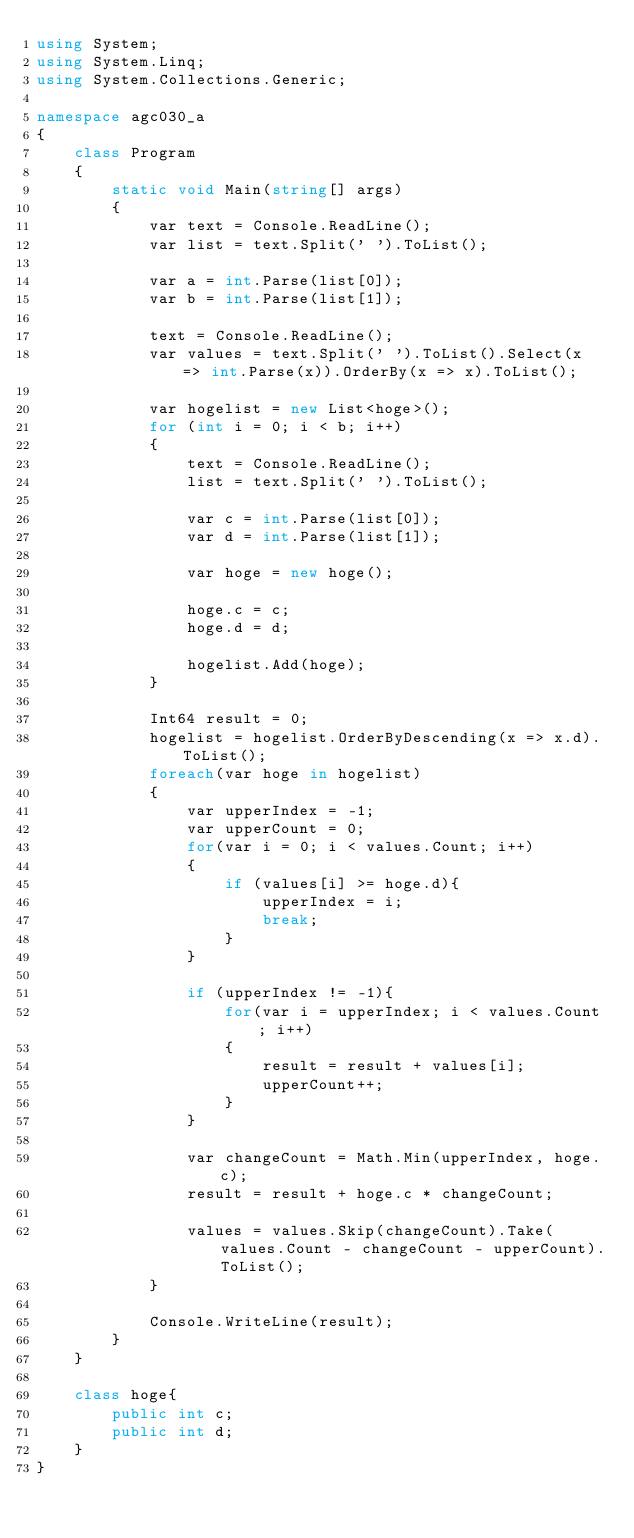<code> <loc_0><loc_0><loc_500><loc_500><_C#_>using System;
using System.Linq;
using System.Collections.Generic;

namespace agc030_a
{
    class Program
    {
        static void Main(string[] args)
        {
            var text = Console.ReadLine();
            var list = text.Split(' ').ToList();

            var a = int.Parse(list[0]);
            var b = int.Parse(list[1]);

            text = Console.ReadLine();
            var values = text.Split(' ').ToList().Select(x => int.Parse(x)).OrderBy(x => x).ToList();

            var hogelist = new List<hoge>();
            for (int i = 0; i < b; i++)
            {
                text = Console.ReadLine();
                list = text.Split(' ').ToList();

                var c = int.Parse(list[0]);
                var d = int.Parse(list[1]);

                var hoge = new hoge();

                hoge.c = c;
                hoge.d = d;

                hogelist.Add(hoge);
            }

            Int64 result = 0;
            hogelist = hogelist.OrderByDescending(x => x.d).ToList();
            foreach(var hoge in hogelist)
            {
                var upperIndex = -1;
                var upperCount = 0;
                for(var i = 0; i < values.Count; i++)
                {
                    if (values[i] >= hoge.d){
                        upperIndex = i;
                        break;
                    }
                }

                if (upperIndex != -1){
                    for(var i = upperIndex; i < values.Count; i++)
                    {
                        result = result + values[i];
                        upperCount++;
                    }
                }
                
                var changeCount = Math.Min(upperIndex, hoge.c);
                result = result + hoge.c * changeCount;

                values = values.Skip(changeCount).Take(values.Count - changeCount - upperCount).ToList();
            }

            Console.WriteLine(result);
        }
    }

    class hoge{
        public int c;
        public int d;
    }
}
</code> 